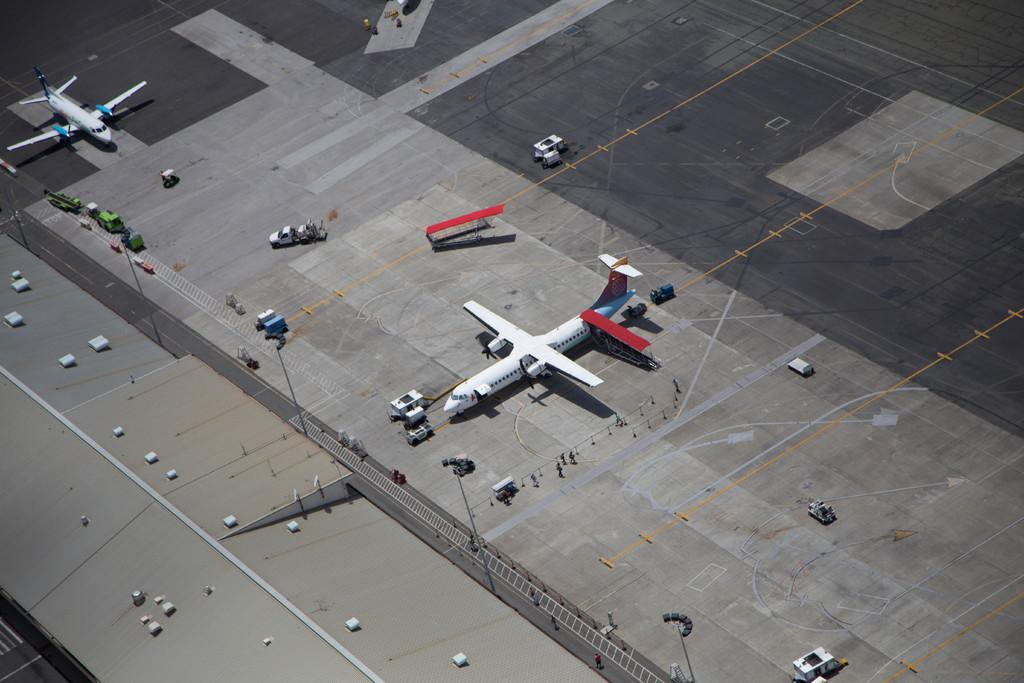What type of setting is depicted in the image? The image is an outside view. What are the main subjects in the image? There are two aeroplanes in the image. What else can be seen on the ground in the image? There are vehicles on the ground in the image. Are there any people visible in the image? Yes, there are people visible in the image. What structure is located on the left side of the image? There is a shed on the left side of the image. Where is the yak grazing in the image? There is no yak present in the image. What type of market can be seen in the image? There is no market visible in the image. 